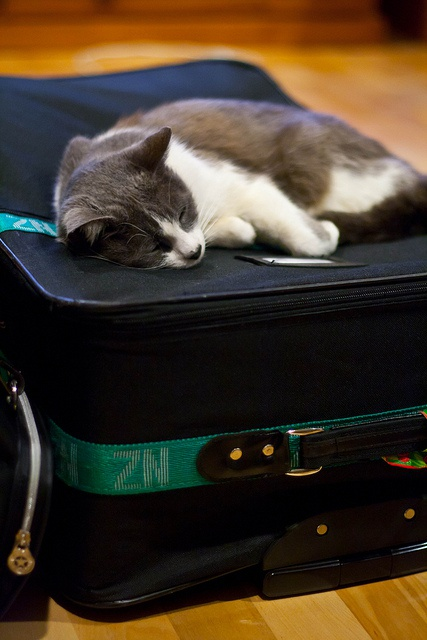Describe the objects in this image and their specific colors. I can see suitcase in black, maroon, blue, and gray tones and cat in maroon, black, gray, lightgray, and darkgray tones in this image. 